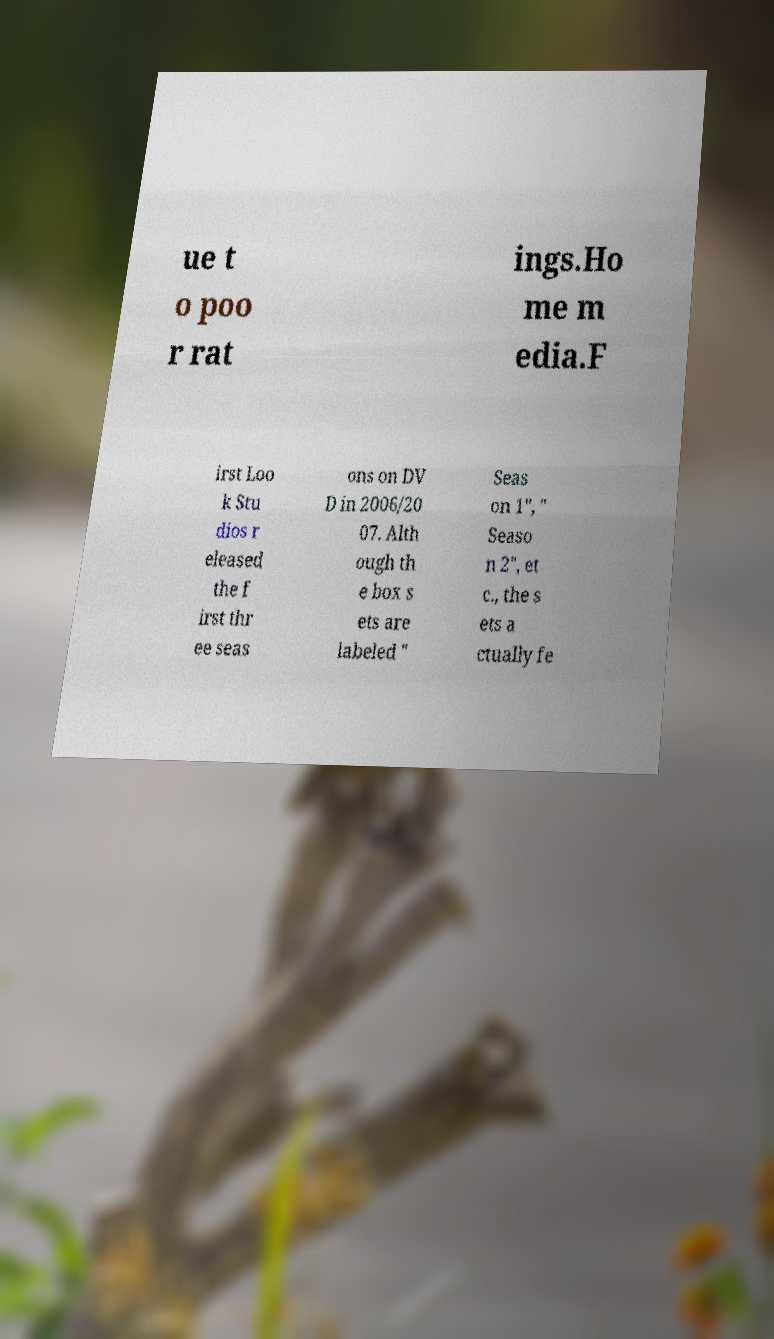I need the written content from this picture converted into text. Can you do that? ue t o poo r rat ings.Ho me m edia.F irst Loo k Stu dios r eleased the f irst thr ee seas ons on DV D in 2006/20 07. Alth ough th e box s ets are labeled " Seas on 1", " Seaso n 2", et c., the s ets a ctually fe 